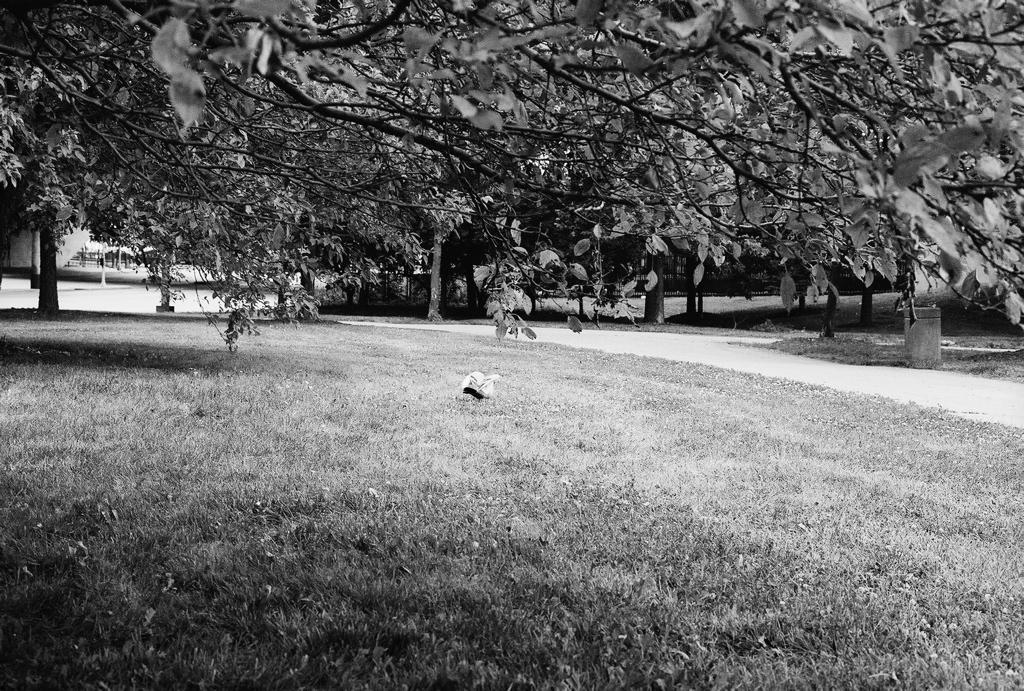Could you give a brief overview of what you see in this image? In this picture I can see many trees, plants and grass. On the left it might be some pole and other structures. 